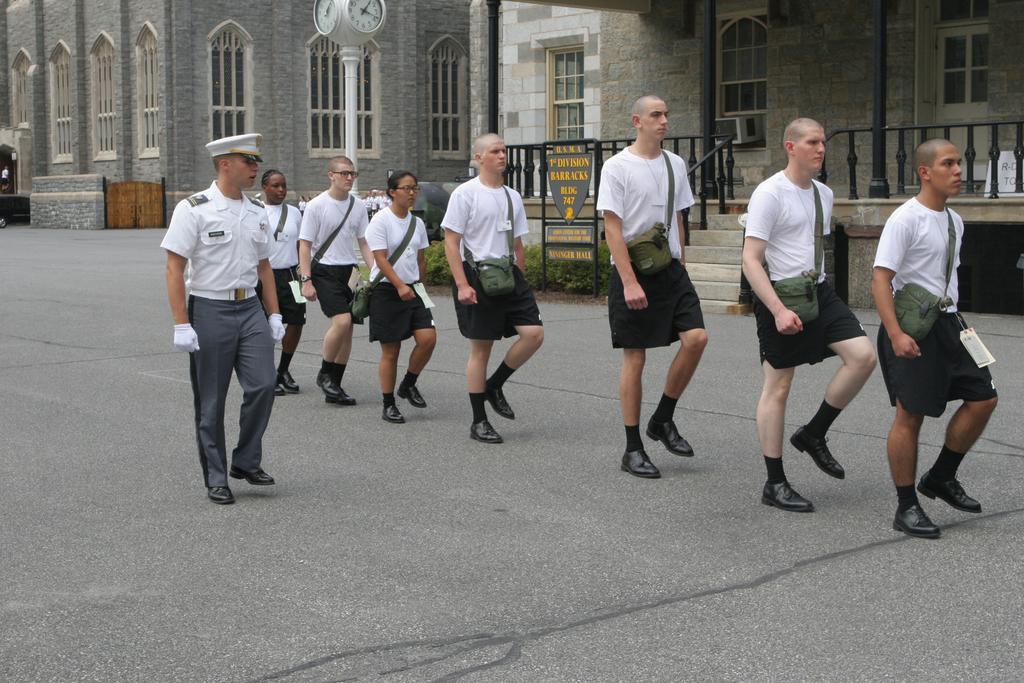In one or two sentences, can you explain what this image depicts? In this image there are people marching on the road. In the background of the image there are buildings. There are windows. There are staircase. At the center of the image there is a clock. 